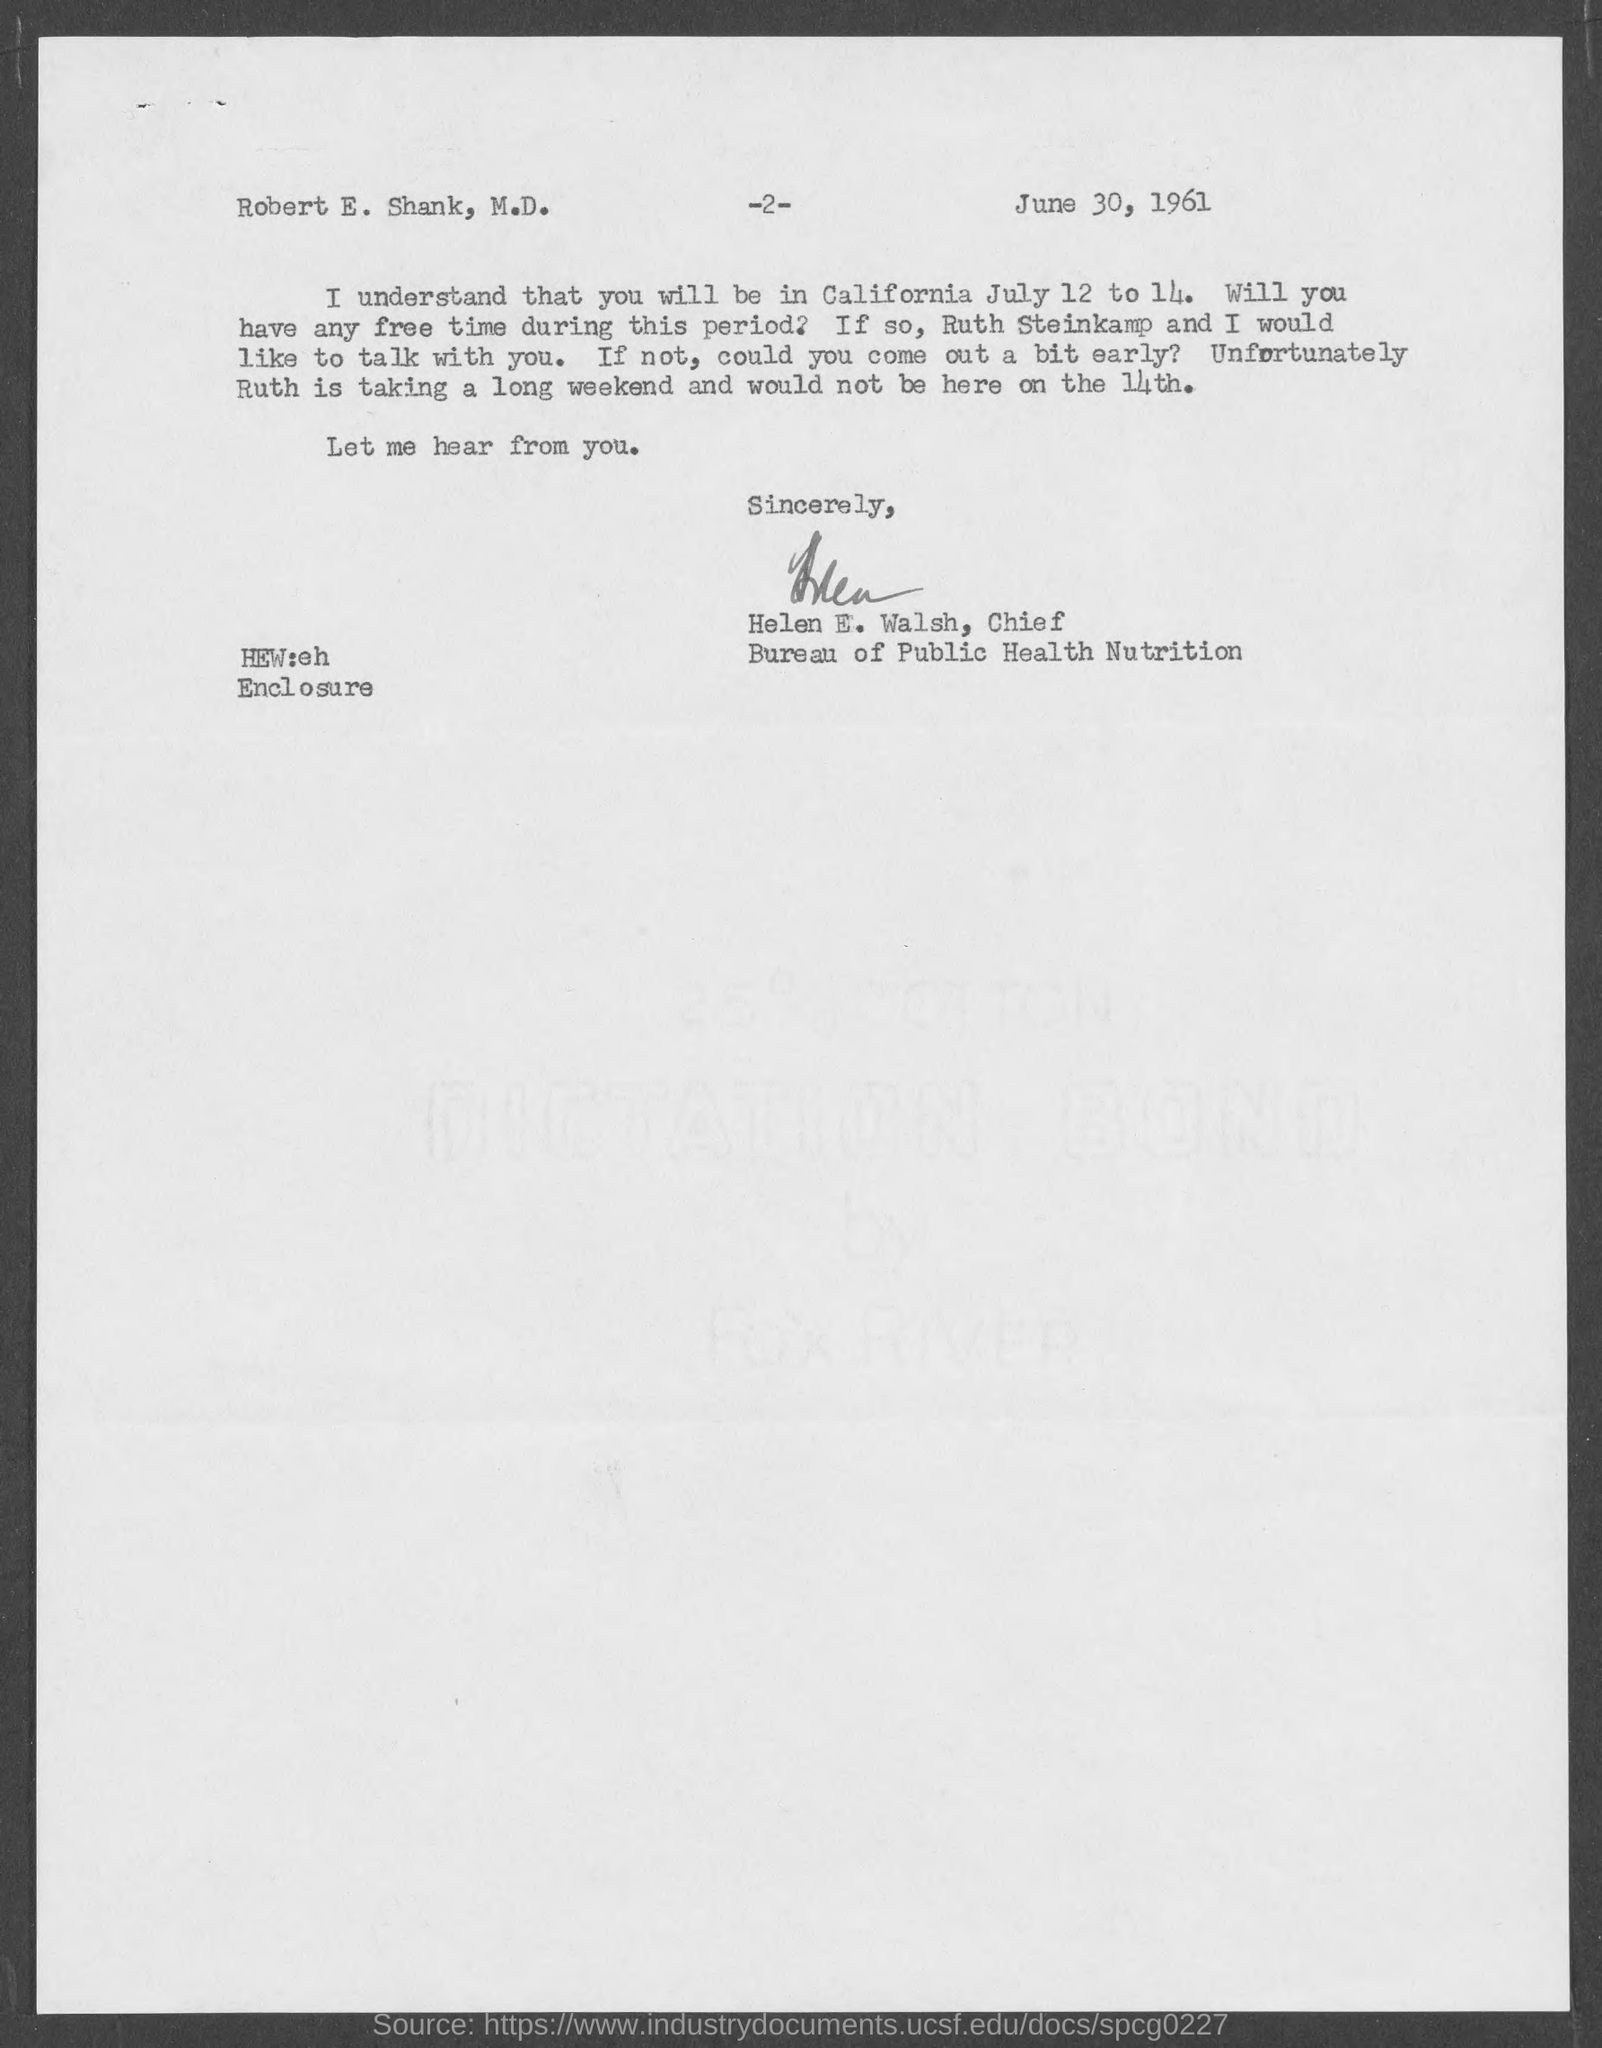What is the page number at top of the page?
Keep it short and to the point. -2-. Who wrote this letter?
Offer a very short reply. HELEN E. WALSH. Who is the chief, bureau of public health nutrition ?
Your answer should be compact. Helen E. Walsh. The letter is dated on?
Your answer should be compact. JUNE 30, 1961. 